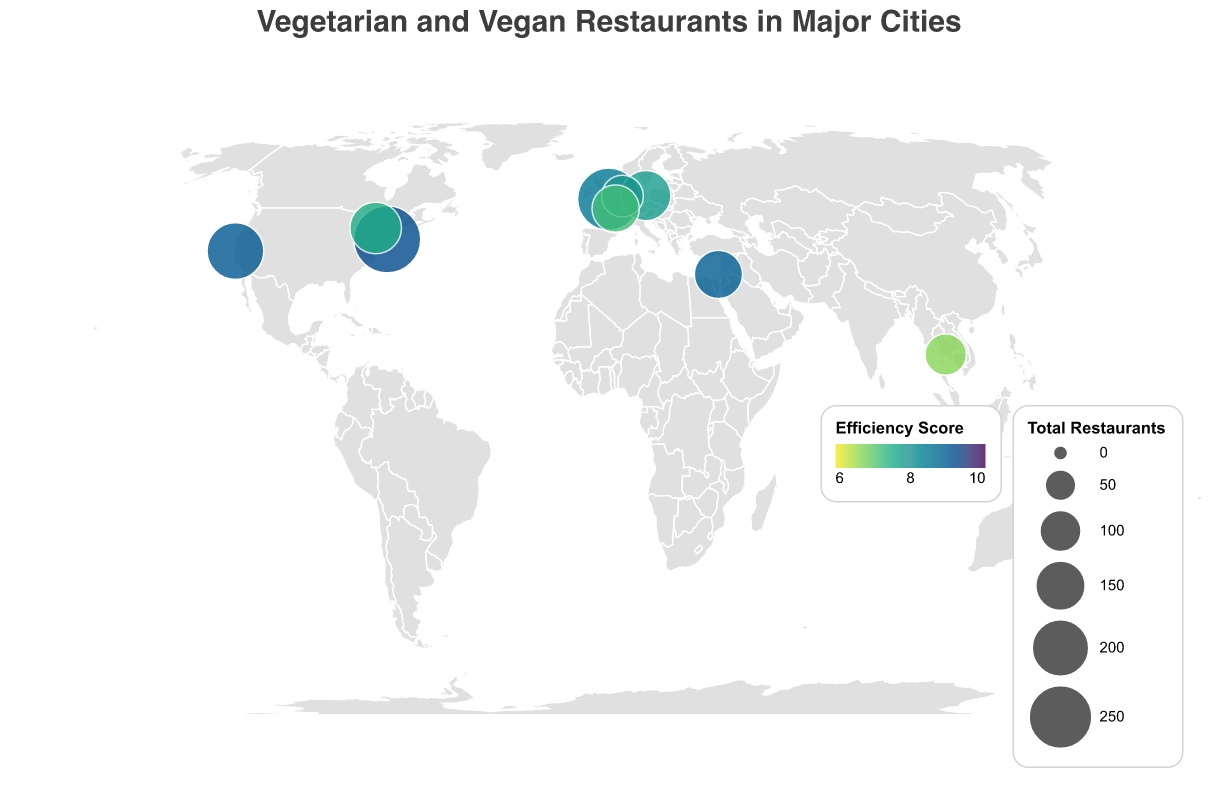How many cities are represented in the figure? There are circles on the map corresponding to different cities with vegetarian and vegan restaurant data. Counting these circles gives the total number of cities represented.
Answer: 10 Which city has the highest efficiency score? The efficiency score is indicated by the color scale. The city with the darkest color will have the highest efficiency score. From the tooltip information, we can identify New York City with an efficiency score of 9.2.
Answer: New York City How does the number of vegan restaurants in Berlin compare to those in Tel Aviv? By looking at the tooltip information for Berlin and Tel Aviv, we can compare the numbers under "Vegan Restaurants." Berlin has 62 vegan restaurants, and Tel Aviv has 43 vegan restaurants. Berlin has more.
Answer: Berlin has more Which city has the smallest total number of vegetarian and vegan restaurants combined? Total restaurants are depicted by the size of the circles. The smallest circle represents the city with the least total number of restaurants. Bangkok, with 98 total restaurants, is the smallest.
Answer: Bangkok What is the difference between the total restaurants in London and Melbourne? To find the difference, look at the size of the circles and the tooltip information. London has 239 total restaurants, and Melbourne has 135. The difference is 239 - 135 = 104.
Answer: 104 Rank the cities based on their efficiency score from highest to lowest. Efficiency scores are indicated by the color scale. Using tooltip data to get specific scores:
1. New York City (9.2)
2. San Francisco (9.0)
3. Tel Aviv (8.9)
4. London (8.5)
5. Melbourne (8.1)
6. Amsterdam (7.9)
7. Berlin (7.8)
8. Toronto (7.5)
9. Paris (7.2)
10. Bangkok (6.7)
Answer: New York City, San Francisco, Tel Aviv, London, Melbourne, Amsterdam, Berlin, Toronto, Paris, Bangkok Which city has a higher efficiency score, Toronto or Paris? Check the tooltip information for Toronto and Paris. Toronto has an efficiency score of 7.5, while Paris has 7.2. So, Toronto has a higher score.
Answer: Toronto How many cities have a total number of restaurants greater than 150? From the tooltip information, identify the cities with total restaurants greater than 150. These include:
- London: 239
- New York City: 281
- San Francisco: 197
- Toronto: 160
Thus, there are 4 cities.
Answer: 4 In which continent are most of the cities with data in this figure located? By observing the geographic positions on the map, we can identify the continents. Most cities (London, Berlin, Tel Aviv, Amsterdam, Paris) are in Europe.
Answer: Europe 